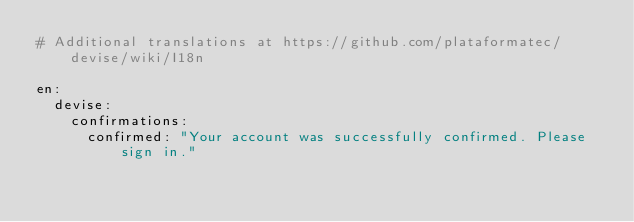<code> <loc_0><loc_0><loc_500><loc_500><_YAML_># Additional translations at https://github.com/plataformatec/devise/wiki/I18n

en:
  devise:
    confirmations:
      confirmed: "Your account was successfully confirmed. Please sign in."</code> 